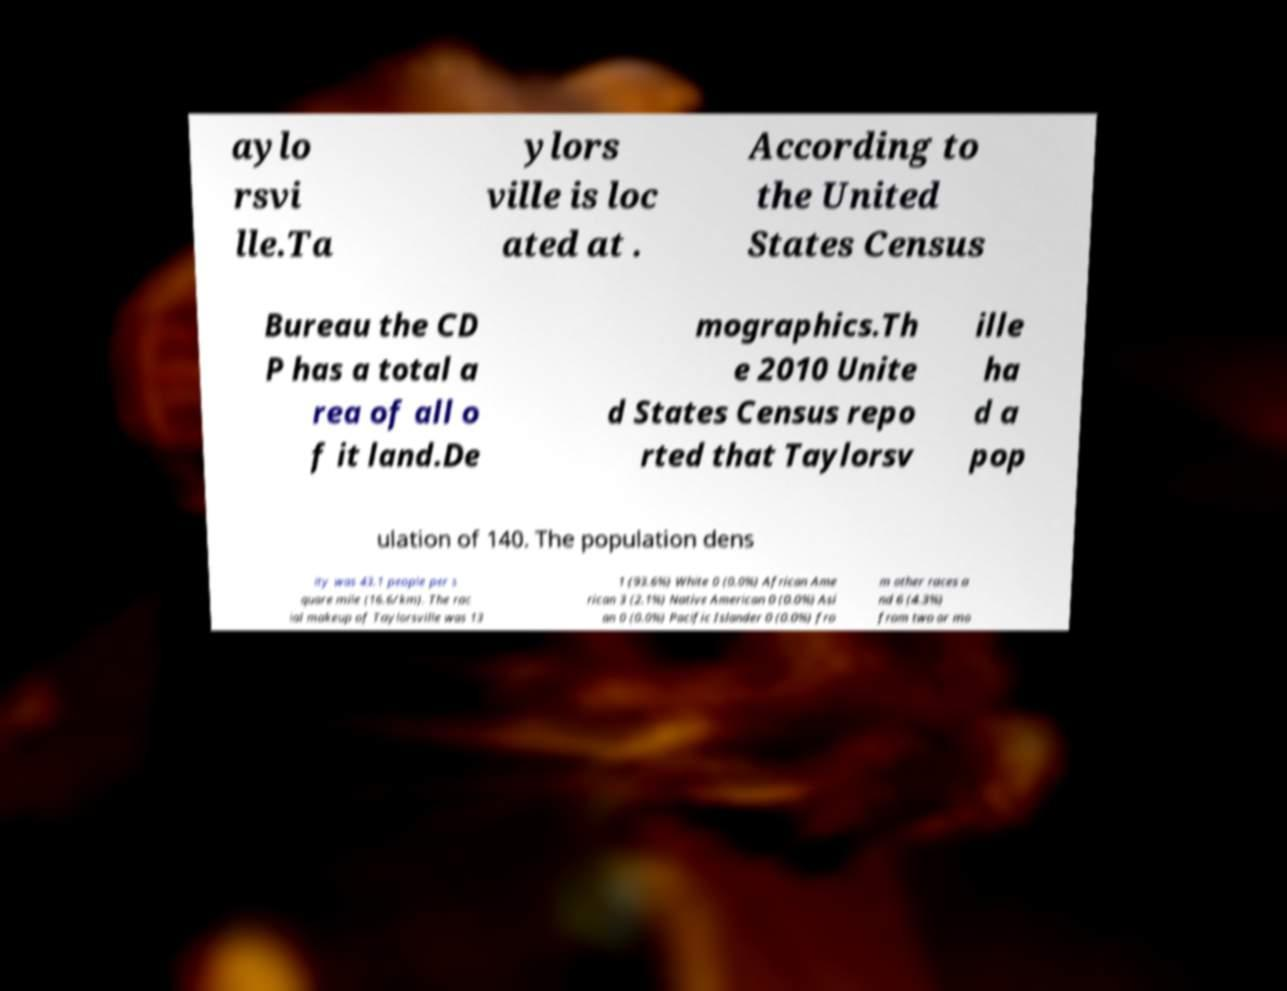Could you assist in decoding the text presented in this image and type it out clearly? aylo rsvi lle.Ta ylors ville is loc ated at . According to the United States Census Bureau the CD P has a total a rea of all o f it land.De mographics.Th e 2010 Unite d States Census repo rted that Taylorsv ille ha d a pop ulation of 140. The population dens ity was 43.1 people per s quare mile (16.6/km). The rac ial makeup of Taylorsville was 13 1 (93.6%) White 0 (0.0%) African Ame rican 3 (2.1%) Native American 0 (0.0%) Asi an 0 (0.0%) Pacific Islander 0 (0.0%) fro m other races a nd 6 (4.3%) from two or mo 